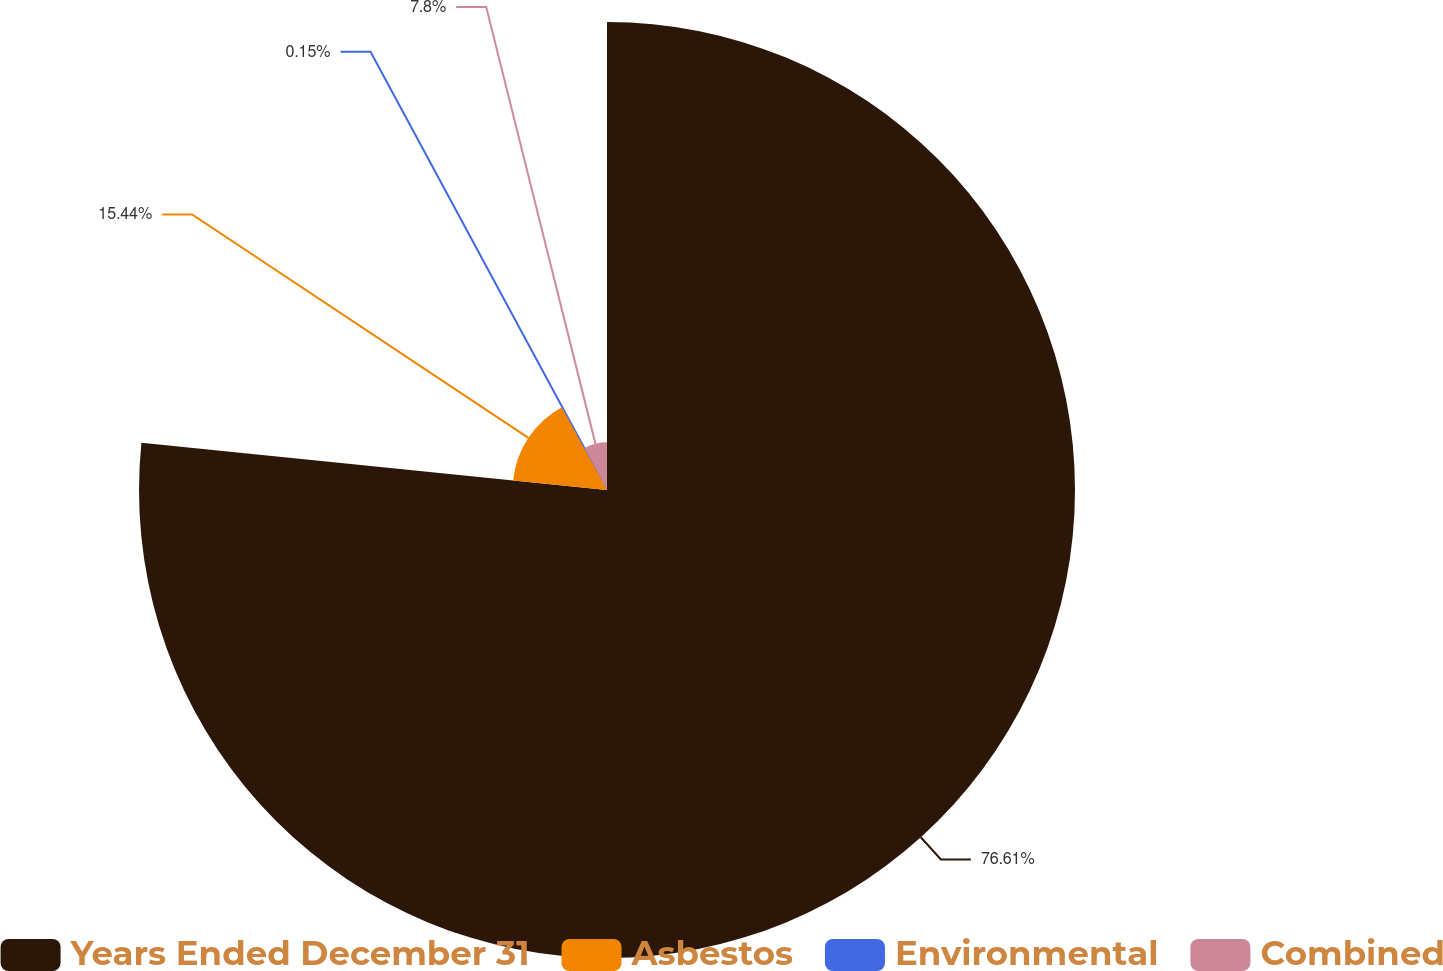Convert chart. <chart><loc_0><loc_0><loc_500><loc_500><pie_chart><fcel>Years Ended December 31<fcel>Asbestos<fcel>Environmental<fcel>Combined<nl><fcel>76.61%<fcel>15.44%<fcel>0.15%<fcel>7.8%<nl></chart> 